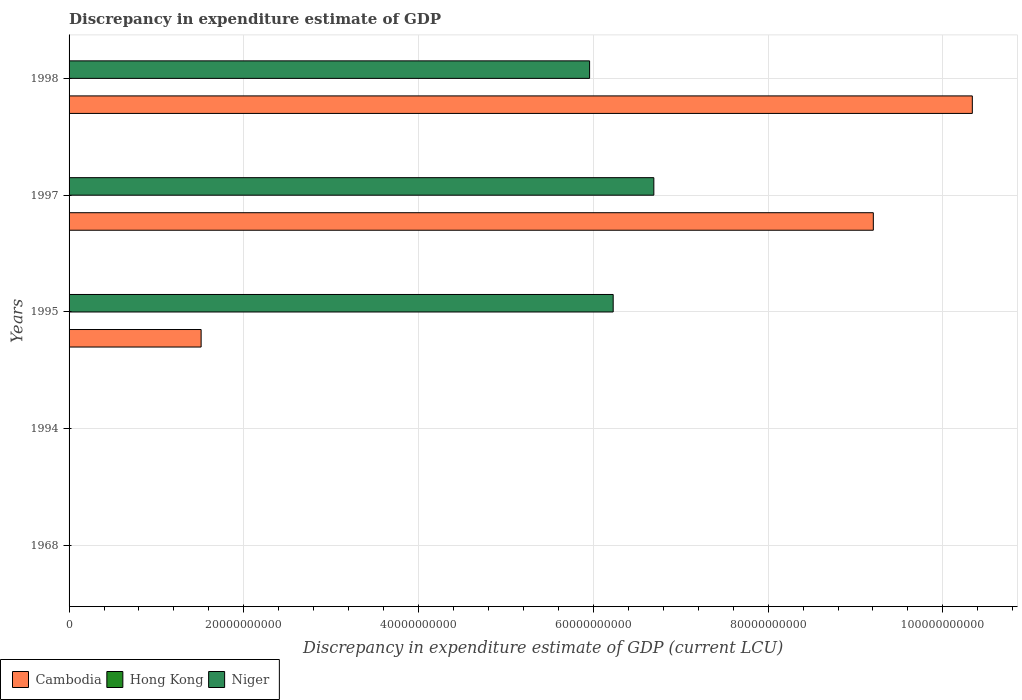How many different coloured bars are there?
Your response must be concise. 3. How many groups of bars are there?
Ensure brevity in your answer.  5. What is the label of the 2nd group of bars from the top?
Your answer should be compact. 1997. In how many cases, is the number of bars for a given year not equal to the number of legend labels?
Make the answer very short. 2. What is the discrepancy in expenditure estimate of GDP in Hong Kong in 1994?
Your answer should be very brief. 0. Across all years, what is the maximum discrepancy in expenditure estimate of GDP in Cambodia?
Provide a succinct answer. 1.03e+11. Across all years, what is the minimum discrepancy in expenditure estimate of GDP in Niger?
Keep it short and to the point. 9200. What is the total discrepancy in expenditure estimate of GDP in Cambodia in the graph?
Provide a short and direct response. 2.11e+11. What is the difference between the discrepancy in expenditure estimate of GDP in Hong Kong in 1997 and that in 1998?
Keep it short and to the point. -6.000000000000001e-5. What is the difference between the discrepancy in expenditure estimate of GDP in Cambodia in 1998 and the discrepancy in expenditure estimate of GDP in Hong Kong in 1968?
Offer a very short reply. 1.03e+11. What is the average discrepancy in expenditure estimate of GDP in Niger per year?
Give a very brief answer. 3.78e+1. In the year 1995, what is the difference between the discrepancy in expenditure estimate of GDP in Cambodia and discrepancy in expenditure estimate of GDP in Hong Kong?
Keep it short and to the point. 1.51e+1. What is the ratio of the discrepancy in expenditure estimate of GDP in Cambodia in 1995 to that in 1997?
Your answer should be compact. 0.16. What is the difference between the highest and the second highest discrepancy in expenditure estimate of GDP in Hong Kong?
Offer a terse response. 0. What is the difference between the highest and the lowest discrepancy in expenditure estimate of GDP in Cambodia?
Give a very brief answer. 1.03e+11. In how many years, is the discrepancy in expenditure estimate of GDP in Niger greater than the average discrepancy in expenditure estimate of GDP in Niger taken over all years?
Your answer should be very brief. 3. How many bars are there?
Give a very brief answer. 13. Are all the bars in the graph horizontal?
Keep it short and to the point. Yes. What is the difference between two consecutive major ticks on the X-axis?
Your answer should be very brief. 2.00e+1. Are the values on the major ticks of X-axis written in scientific E-notation?
Ensure brevity in your answer.  No. Does the graph contain grids?
Your answer should be compact. Yes. How are the legend labels stacked?
Provide a short and direct response. Horizontal. What is the title of the graph?
Provide a short and direct response. Discrepancy in expenditure estimate of GDP. What is the label or title of the X-axis?
Give a very brief answer. Discrepancy in expenditure estimate of GDP (current LCU). What is the Discrepancy in expenditure estimate of GDP (current LCU) in Cambodia in 1968?
Keep it short and to the point. 100. What is the Discrepancy in expenditure estimate of GDP (current LCU) of Niger in 1968?
Your answer should be very brief. 9200. What is the Discrepancy in expenditure estimate of GDP (current LCU) of Hong Kong in 1994?
Your answer should be very brief. 0. What is the Discrepancy in expenditure estimate of GDP (current LCU) in Niger in 1994?
Your answer should be very brief. 1.63e+07. What is the Discrepancy in expenditure estimate of GDP (current LCU) of Cambodia in 1995?
Keep it short and to the point. 1.51e+1. What is the Discrepancy in expenditure estimate of GDP (current LCU) of Hong Kong in 1995?
Your answer should be compact. 0. What is the Discrepancy in expenditure estimate of GDP (current LCU) of Niger in 1995?
Give a very brief answer. 6.23e+1. What is the Discrepancy in expenditure estimate of GDP (current LCU) in Cambodia in 1997?
Offer a terse response. 9.20e+1. What is the Discrepancy in expenditure estimate of GDP (current LCU) of Hong Kong in 1997?
Provide a short and direct response. 2e-5. What is the Discrepancy in expenditure estimate of GDP (current LCU) in Niger in 1997?
Your answer should be compact. 6.69e+1. What is the Discrepancy in expenditure estimate of GDP (current LCU) in Cambodia in 1998?
Offer a terse response. 1.03e+11. What is the Discrepancy in expenditure estimate of GDP (current LCU) of Hong Kong in 1998?
Your answer should be compact. 8e-5. What is the Discrepancy in expenditure estimate of GDP (current LCU) in Niger in 1998?
Your answer should be compact. 5.96e+1. Across all years, what is the maximum Discrepancy in expenditure estimate of GDP (current LCU) in Cambodia?
Your response must be concise. 1.03e+11. Across all years, what is the maximum Discrepancy in expenditure estimate of GDP (current LCU) in Hong Kong?
Provide a short and direct response. 0. Across all years, what is the maximum Discrepancy in expenditure estimate of GDP (current LCU) in Niger?
Give a very brief answer. 6.69e+1. Across all years, what is the minimum Discrepancy in expenditure estimate of GDP (current LCU) of Hong Kong?
Ensure brevity in your answer.  0. Across all years, what is the minimum Discrepancy in expenditure estimate of GDP (current LCU) in Niger?
Offer a terse response. 9200. What is the total Discrepancy in expenditure estimate of GDP (current LCU) in Cambodia in the graph?
Your answer should be compact. 2.11e+11. What is the total Discrepancy in expenditure estimate of GDP (current LCU) in Hong Kong in the graph?
Your answer should be compact. 0. What is the total Discrepancy in expenditure estimate of GDP (current LCU) in Niger in the graph?
Keep it short and to the point. 1.89e+11. What is the difference between the Discrepancy in expenditure estimate of GDP (current LCU) in Niger in 1968 and that in 1994?
Offer a terse response. -1.63e+07. What is the difference between the Discrepancy in expenditure estimate of GDP (current LCU) in Cambodia in 1968 and that in 1995?
Your response must be concise. -1.51e+1. What is the difference between the Discrepancy in expenditure estimate of GDP (current LCU) in Niger in 1968 and that in 1995?
Offer a very short reply. -6.23e+1. What is the difference between the Discrepancy in expenditure estimate of GDP (current LCU) of Cambodia in 1968 and that in 1997?
Your answer should be very brief. -9.20e+1. What is the difference between the Discrepancy in expenditure estimate of GDP (current LCU) in Niger in 1968 and that in 1997?
Give a very brief answer. -6.69e+1. What is the difference between the Discrepancy in expenditure estimate of GDP (current LCU) of Cambodia in 1968 and that in 1998?
Provide a succinct answer. -1.03e+11. What is the difference between the Discrepancy in expenditure estimate of GDP (current LCU) of Niger in 1968 and that in 1998?
Ensure brevity in your answer.  -5.96e+1. What is the difference between the Discrepancy in expenditure estimate of GDP (current LCU) of Hong Kong in 1994 and that in 1995?
Offer a terse response. 0. What is the difference between the Discrepancy in expenditure estimate of GDP (current LCU) of Niger in 1994 and that in 1995?
Your response must be concise. -6.23e+1. What is the difference between the Discrepancy in expenditure estimate of GDP (current LCU) of Niger in 1994 and that in 1997?
Offer a terse response. -6.69e+1. What is the difference between the Discrepancy in expenditure estimate of GDP (current LCU) of Hong Kong in 1994 and that in 1998?
Keep it short and to the point. 0. What is the difference between the Discrepancy in expenditure estimate of GDP (current LCU) in Niger in 1994 and that in 1998?
Provide a short and direct response. -5.96e+1. What is the difference between the Discrepancy in expenditure estimate of GDP (current LCU) in Cambodia in 1995 and that in 1997?
Offer a terse response. -7.69e+1. What is the difference between the Discrepancy in expenditure estimate of GDP (current LCU) of Hong Kong in 1995 and that in 1997?
Ensure brevity in your answer.  0. What is the difference between the Discrepancy in expenditure estimate of GDP (current LCU) in Niger in 1995 and that in 1997?
Your answer should be compact. -4.65e+09. What is the difference between the Discrepancy in expenditure estimate of GDP (current LCU) of Cambodia in 1995 and that in 1998?
Offer a terse response. -8.83e+1. What is the difference between the Discrepancy in expenditure estimate of GDP (current LCU) of Hong Kong in 1995 and that in 1998?
Give a very brief answer. 0. What is the difference between the Discrepancy in expenditure estimate of GDP (current LCU) in Niger in 1995 and that in 1998?
Offer a very short reply. 2.70e+09. What is the difference between the Discrepancy in expenditure estimate of GDP (current LCU) of Cambodia in 1997 and that in 1998?
Offer a terse response. -1.13e+1. What is the difference between the Discrepancy in expenditure estimate of GDP (current LCU) of Hong Kong in 1997 and that in 1998?
Offer a terse response. -0. What is the difference between the Discrepancy in expenditure estimate of GDP (current LCU) of Niger in 1997 and that in 1998?
Your answer should be very brief. 7.35e+09. What is the difference between the Discrepancy in expenditure estimate of GDP (current LCU) of Cambodia in 1968 and the Discrepancy in expenditure estimate of GDP (current LCU) of Hong Kong in 1994?
Provide a succinct answer. 100. What is the difference between the Discrepancy in expenditure estimate of GDP (current LCU) of Cambodia in 1968 and the Discrepancy in expenditure estimate of GDP (current LCU) of Niger in 1994?
Provide a succinct answer. -1.63e+07. What is the difference between the Discrepancy in expenditure estimate of GDP (current LCU) in Cambodia in 1968 and the Discrepancy in expenditure estimate of GDP (current LCU) in Hong Kong in 1995?
Your answer should be compact. 100. What is the difference between the Discrepancy in expenditure estimate of GDP (current LCU) in Cambodia in 1968 and the Discrepancy in expenditure estimate of GDP (current LCU) in Niger in 1995?
Provide a succinct answer. -6.23e+1. What is the difference between the Discrepancy in expenditure estimate of GDP (current LCU) of Cambodia in 1968 and the Discrepancy in expenditure estimate of GDP (current LCU) of Niger in 1997?
Your answer should be very brief. -6.69e+1. What is the difference between the Discrepancy in expenditure estimate of GDP (current LCU) of Cambodia in 1968 and the Discrepancy in expenditure estimate of GDP (current LCU) of Hong Kong in 1998?
Provide a succinct answer. 100. What is the difference between the Discrepancy in expenditure estimate of GDP (current LCU) in Cambodia in 1968 and the Discrepancy in expenditure estimate of GDP (current LCU) in Niger in 1998?
Provide a succinct answer. -5.96e+1. What is the difference between the Discrepancy in expenditure estimate of GDP (current LCU) in Hong Kong in 1994 and the Discrepancy in expenditure estimate of GDP (current LCU) in Niger in 1995?
Your answer should be very brief. -6.23e+1. What is the difference between the Discrepancy in expenditure estimate of GDP (current LCU) of Hong Kong in 1994 and the Discrepancy in expenditure estimate of GDP (current LCU) of Niger in 1997?
Keep it short and to the point. -6.69e+1. What is the difference between the Discrepancy in expenditure estimate of GDP (current LCU) in Hong Kong in 1994 and the Discrepancy in expenditure estimate of GDP (current LCU) in Niger in 1998?
Your response must be concise. -5.96e+1. What is the difference between the Discrepancy in expenditure estimate of GDP (current LCU) of Cambodia in 1995 and the Discrepancy in expenditure estimate of GDP (current LCU) of Hong Kong in 1997?
Your response must be concise. 1.51e+1. What is the difference between the Discrepancy in expenditure estimate of GDP (current LCU) of Cambodia in 1995 and the Discrepancy in expenditure estimate of GDP (current LCU) of Niger in 1997?
Your answer should be compact. -5.18e+1. What is the difference between the Discrepancy in expenditure estimate of GDP (current LCU) of Hong Kong in 1995 and the Discrepancy in expenditure estimate of GDP (current LCU) of Niger in 1997?
Offer a terse response. -6.69e+1. What is the difference between the Discrepancy in expenditure estimate of GDP (current LCU) of Cambodia in 1995 and the Discrepancy in expenditure estimate of GDP (current LCU) of Hong Kong in 1998?
Offer a very short reply. 1.51e+1. What is the difference between the Discrepancy in expenditure estimate of GDP (current LCU) in Cambodia in 1995 and the Discrepancy in expenditure estimate of GDP (current LCU) in Niger in 1998?
Keep it short and to the point. -4.45e+1. What is the difference between the Discrepancy in expenditure estimate of GDP (current LCU) of Hong Kong in 1995 and the Discrepancy in expenditure estimate of GDP (current LCU) of Niger in 1998?
Your answer should be compact. -5.96e+1. What is the difference between the Discrepancy in expenditure estimate of GDP (current LCU) of Cambodia in 1997 and the Discrepancy in expenditure estimate of GDP (current LCU) of Hong Kong in 1998?
Provide a short and direct response. 9.20e+1. What is the difference between the Discrepancy in expenditure estimate of GDP (current LCU) in Cambodia in 1997 and the Discrepancy in expenditure estimate of GDP (current LCU) in Niger in 1998?
Offer a very short reply. 3.25e+1. What is the difference between the Discrepancy in expenditure estimate of GDP (current LCU) in Hong Kong in 1997 and the Discrepancy in expenditure estimate of GDP (current LCU) in Niger in 1998?
Give a very brief answer. -5.96e+1. What is the average Discrepancy in expenditure estimate of GDP (current LCU) in Cambodia per year?
Provide a short and direct response. 4.21e+1. What is the average Discrepancy in expenditure estimate of GDP (current LCU) in Hong Kong per year?
Provide a short and direct response. 0. What is the average Discrepancy in expenditure estimate of GDP (current LCU) of Niger per year?
Your answer should be compact. 3.78e+1. In the year 1968, what is the difference between the Discrepancy in expenditure estimate of GDP (current LCU) in Cambodia and Discrepancy in expenditure estimate of GDP (current LCU) in Niger?
Ensure brevity in your answer.  -9100. In the year 1994, what is the difference between the Discrepancy in expenditure estimate of GDP (current LCU) in Hong Kong and Discrepancy in expenditure estimate of GDP (current LCU) in Niger?
Provide a short and direct response. -1.63e+07. In the year 1995, what is the difference between the Discrepancy in expenditure estimate of GDP (current LCU) of Cambodia and Discrepancy in expenditure estimate of GDP (current LCU) of Hong Kong?
Ensure brevity in your answer.  1.51e+1. In the year 1995, what is the difference between the Discrepancy in expenditure estimate of GDP (current LCU) of Cambodia and Discrepancy in expenditure estimate of GDP (current LCU) of Niger?
Make the answer very short. -4.72e+1. In the year 1995, what is the difference between the Discrepancy in expenditure estimate of GDP (current LCU) of Hong Kong and Discrepancy in expenditure estimate of GDP (current LCU) of Niger?
Offer a very short reply. -6.23e+1. In the year 1997, what is the difference between the Discrepancy in expenditure estimate of GDP (current LCU) of Cambodia and Discrepancy in expenditure estimate of GDP (current LCU) of Hong Kong?
Offer a very short reply. 9.20e+1. In the year 1997, what is the difference between the Discrepancy in expenditure estimate of GDP (current LCU) of Cambodia and Discrepancy in expenditure estimate of GDP (current LCU) of Niger?
Offer a terse response. 2.51e+1. In the year 1997, what is the difference between the Discrepancy in expenditure estimate of GDP (current LCU) of Hong Kong and Discrepancy in expenditure estimate of GDP (current LCU) of Niger?
Your answer should be compact. -6.69e+1. In the year 1998, what is the difference between the Discrepancy in expenditure estimate of GDP (current LCU) in Cambodia and Discrepancy in expenditure estimate of GDP (current LCU) in Hong Kong?
Your answer should be compact. 1.03e+11. In the year 1998, what is the difference between the Discrepancy in expenditure estimate of GDP (current LCU) in Cambodia and Discrepancy in expenditure estimate of GDP (current LCU) in Niger?
Provide a succinct answer. 4.38e+1. In the year 1998, what is the difference between the Discrepancy in expenditure estimate of GDP (current LCU) of Hong Kong and Discrepancy in expenditure estimate of GDP (current LCU) of Niger?
Your answer should be compact. -5.96e+1. What is the ratio of the Discrepancy in expenditure estimate of GDP (current LCU) in Niger in 1968 to that in 1994?
Offer a very short reply. 0. What is the ratio of the Discrepancy in expenditure estimate of GDP (current LCU) in Cambodia in 1968 to that in 1995?
Your answer should be very brief. 0. What is the ratio of the Discrepancy in expenditure estimate of GDP (current LCU) in Cambodia in 1968 to that in 1998?
Your response must be concise. 0. What is the ratio of the Discrepancy in expenditure estimate of GDP (current LCU) in Niger in 1968 to that in 1998?
Make the answer very short. 0. What is the ratio of the Discrepancy in expenditure estimate of GDP (current LCU) in Hong Kong in 1994 to that in 1995?
Provide a succinct answer. 1.62. What is the ratio of the Discrepancy in expenditure estimate of GDP (current LCU) in Niger in 1994 to that in 1995?
Give a very brief answer. 0. What is the ratio of the Discrepancy in expenditure estimate of GDP (current LCU) of Niger in 1994 to that in 1997?
Ensure brevity in your answer.  0. What is the ratio of the Discrepancy in expenditure estimate of GDP (current LCU) of Hong Kong in 1994 to that in 1998?
Provide a succinct answer. 3.75. What is the ratio of the Discrepancy in expenditure estimate of GDP (current LCU) of Niger in 1994 to that in 1998?
Offer a very short reply. 0. What is the ratio of the Discrepancy in expenditure estimate of GDP (current LCU) in Cambodia in 1995 to that in 1997?
Your answer should be compact. 0.16. What is the ratio of the Discrepancy in expenditure estimate of GDP (current LCU) of Hong Kong in 1995 to that in 1997?
Keep it short and to the point. 9.25. What is the ratio of the Discrepancy in expenditure estimate of GDP (current LCU) of Niger in 1995 to that in 1997?
Keep it short and to the point. 0.93. What is the ratio of the Discrepancy in expenditure estimate of GDP (current LCU) in Cambodia in 1995 to that in 1998?
Your answer should be compact. 0.15. What is the ratio of the Discrepancy in expenditure estimate of GDP (current LCU) in Hong Kong in 1995 to that in 1998?
Ensure brevity in your answer.  2.31. What is the ratio of the Discrepancy in expenditure estimate of GDP (current LCU) of Niger in 1995 to that in 1998?
Your response must be concise. 1.05. What is the ratio of the Discrepancy in expenditure estimate of GDP (current LCU) in Cambodia in 1997 to that in 1998?
Provide a short and direct response. 0.89. What is the ratio of the Discrepancy in expenditure estimate of GDP (current LCU) of Niger in 1997 to that in 1998?
Make the answer very short. 1.12. What is the difference between the highest and the second highest Discrepancy in expenditure estimate of GDP (current LCU) of Cambodia?
Offer a very short reply. 1.13e+1. What is the difference between the highest and the second highest Discrepancy in expenditure estimate of GDP (current LCU) in Niger?
Provide a short and direct response. 4.65e+09. What is the difference between the highest and the lowest Discrepancy in expenditure estimate of GDP (current LCU) in Cambodia?
Offer a terse response. 1.03e+11. What is the difference between the highest and the lowest Discrepancy in expenditure estimate of GDP (current LCU) of Hong Kong?
Provide a short and direct response. 0. What is the difference between the highest and the lowest Discrepancy in expenditure estimate of GDP (current LCU) of Niger?
Make the answer very short. 6.69e+1. 